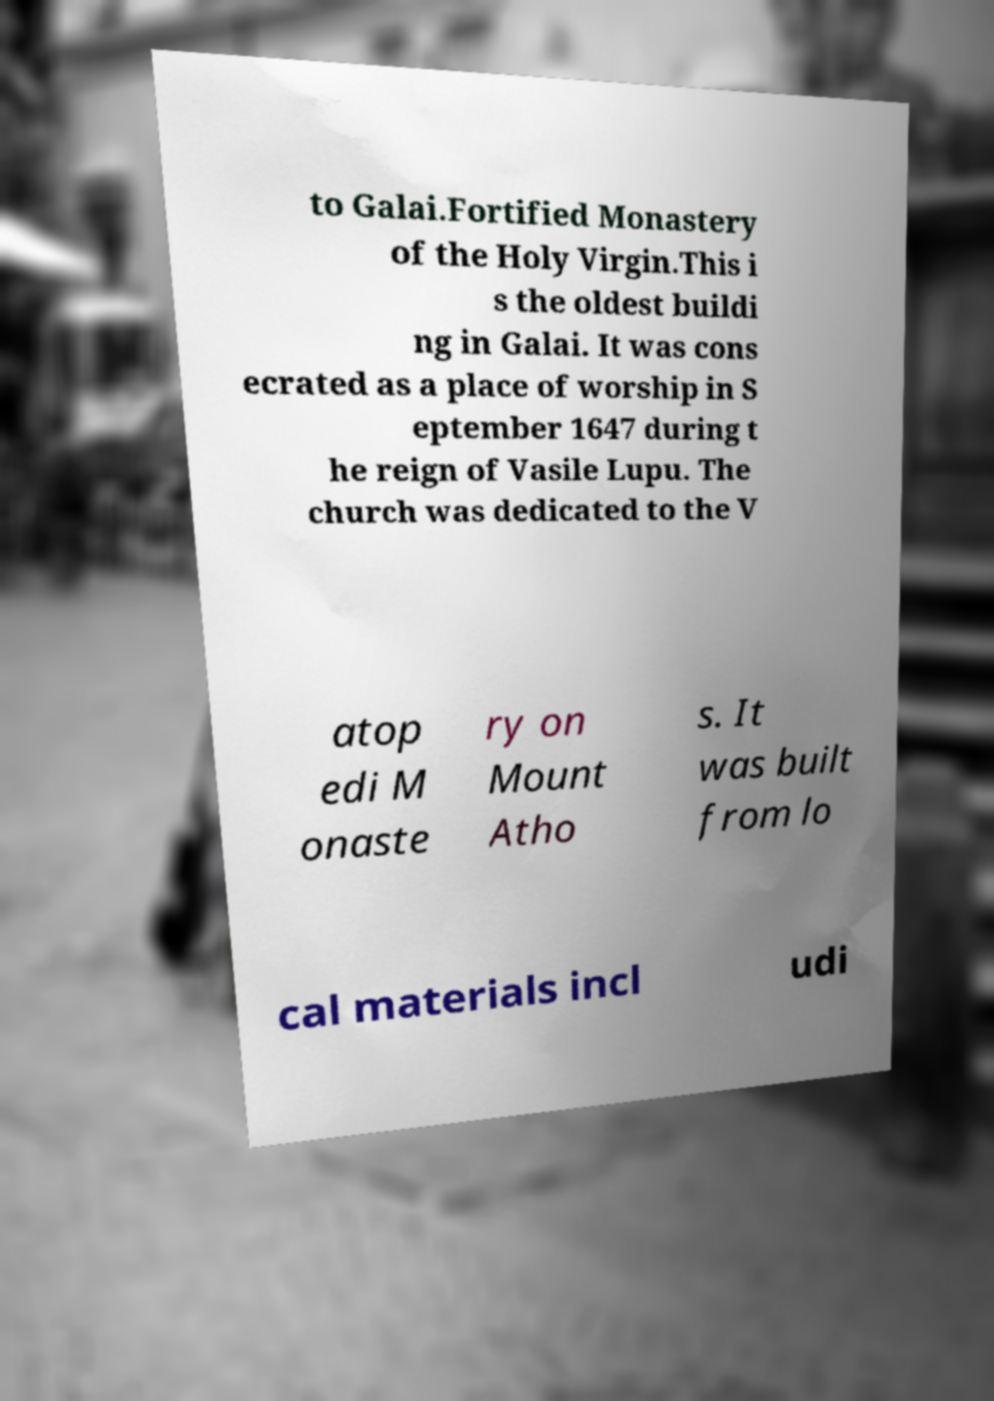I need the written content from this picture converted into text. Can you do that? to Galai.Fortified Monastery of the Holy Virgin.This i s the oldest buildi ng in Galai. It was cons ecrated as a place of worship in S eptember 1647 during t he reign of Vasile Lupu. The church was dedicated to the V atop edi M onaste ry on Mount Atho s. It was built from lo cal materials incl udi 